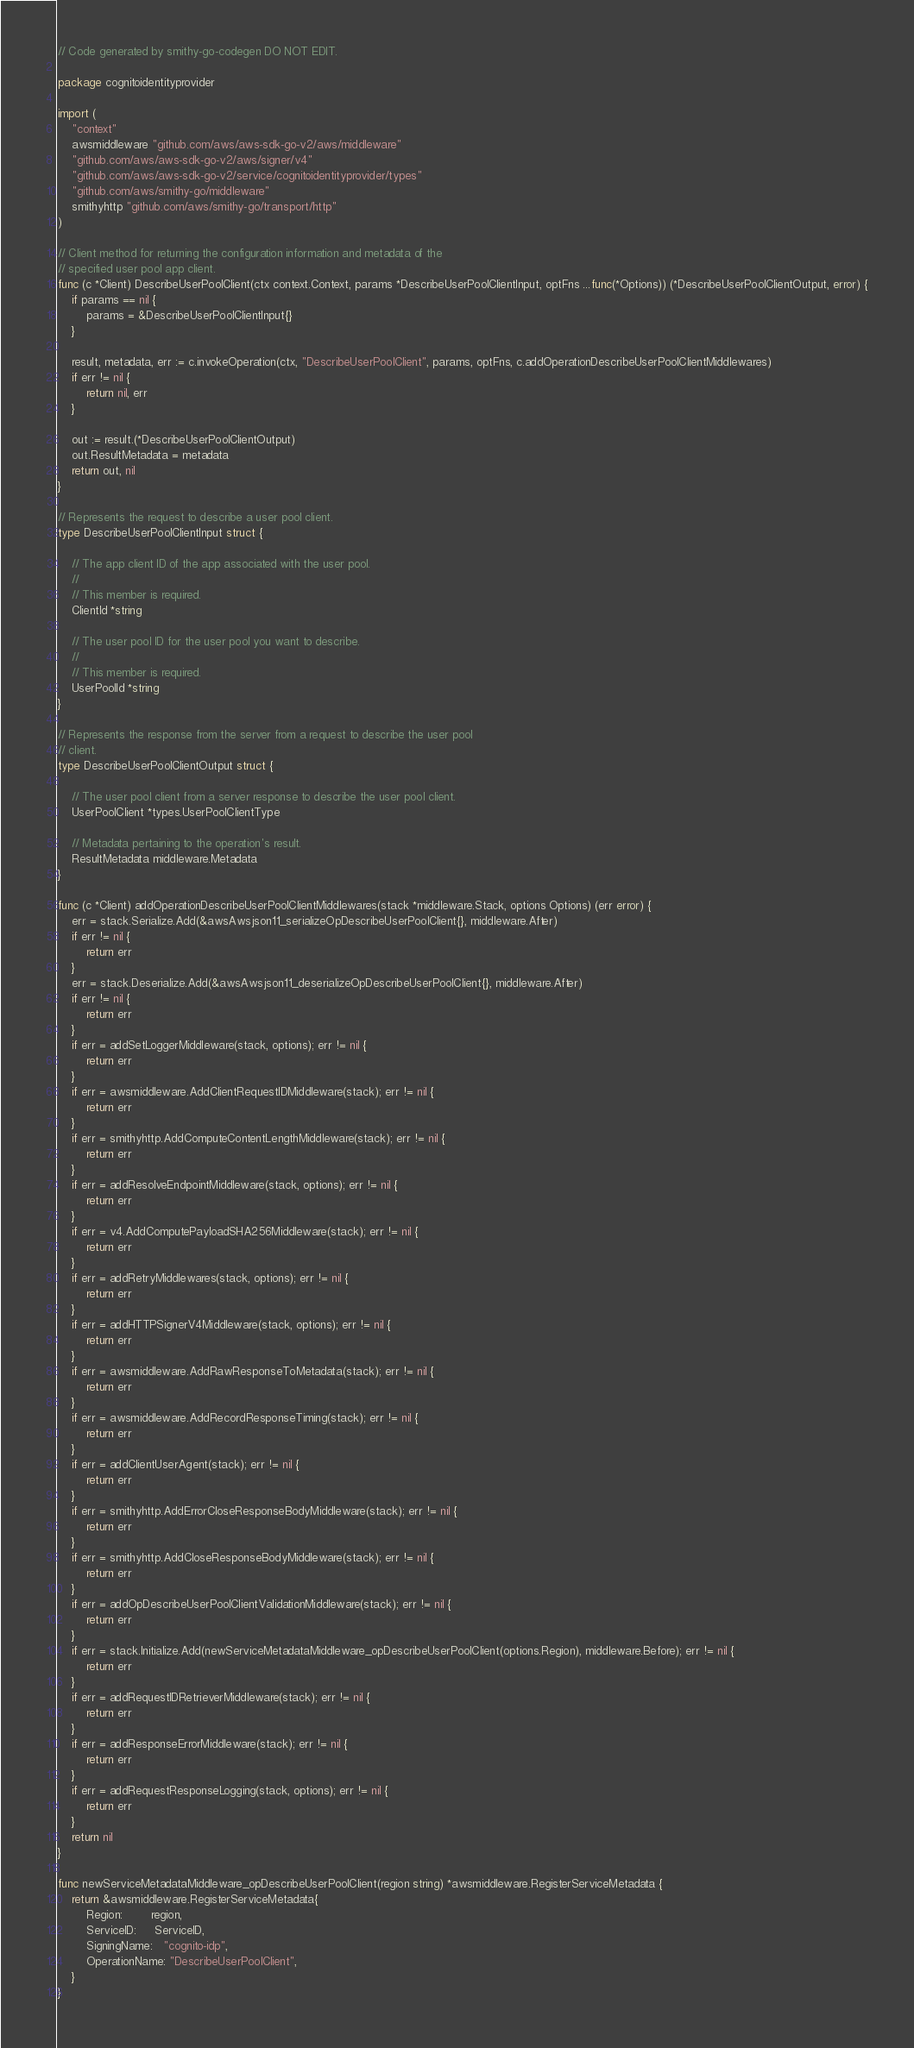Convert code to text. <code><loc_0><loc_0><loc_500><loc_500><_Go_>// Code generated by smithy-go-codegen DO NOT EDIT.

package cognitoidentityprovider

import (
	"context"
	awsmiddleware "github.com/aws/aws-sdk-go-v2/aws/middleware"
	"github.com/aws/aws-sdk-go-v2/aws/signer/v4"
	"github.com/aws/aws-sdk-go-v2/service/cognitoidentityprovider/types"
	"github.com/aws/smithy-go/middleware"
	smithyhttp "github.com/aws/smithy-go/transport/http"
)

// Client method for returning the configuration information and metadata of the
// specified user pool app client.
func (c *Client) DescribeUserPoolClient(ctx context.Context, params *DescribeUserPoolClientInput, optFns ...func(*Options)) (*DescribeUserPoolClientOutput, error) {
	if params == nil {
		params = &DescribeUserPoolClientInput{}
	}

	result, metadata, err := c.invokeOperation(ctx, "DescribeUserPoolClient", params, optFns, c.addOperationDescribeUserPoolClientMiddlewares)
	if err != nil {
		return nil, err
	}

	out := result.(*DescribeUserPoolClientOutput)
	out.ResultMetadata = metadata
	return out, nil
}

// Represents the request to describe a user pool client.
type DescribeUserPoolClientInput struct {

	// The app client ID of the app associated with the user pool.
	//
	// This member is required.
	ClientId *string

	// The user pool ID for the user pool you want to describe.
	//
	// This member is required.
	UserPoolId *string
}

// Represents the response from the server from a request to describe the user pool
// client.
type DescribeUserPoolClientOutput struct {

	// The user pool client from a server response to describe the user pool client.
	UserPoolClient *types.UserPoolClientType

	// Metadata pertaining to the operation's result.
	ResultMetadata middleware.Metadata
}

func (c *Client) addOperationDescribeUserPoolClientMiddlewares(stack *middleware.Stack, options Options) (err error) {
	err = stack.Serialize.Add(&awsAwsjson11_serializeOpDescribeUserPoolClient{}, middleware.After)
	if err != nil {
		return err
	}
	err = stack.Deserialize.Add(&awsAwsjson11_deserializeOpDescribeUserPoolClient{}, middleware.After)
	if err != nil {
		return err
	}
	if err = addSetLoggerMiddleware(stack, options); err != nil {
		return err
	}
	if err = awsmiddleware.AddClientRequestIDMiddleware(stack); err != nil {
		return err
	}
	if err = smithyhttp.AddComputeContentLengthMiddleware(stack); err != nil {
		return err
	}
	if err = addResolveEndpointMiddleware(stack, options); err != nil {
		return err
	}
	if err = v4.AddComputePayloadSHA256Middleware(stack); err != nil {
		return err
	}
	if err = addRetryMiddlewares(stack, options); err != nil {
		return err
	}
	if err = addHTTPSignerV4Middleware(stack, options); err != nil {
		return err
	}
	if err = awsmiddleware.AddRawResponseToMetadata(stack); err != nil {
		return err
	}
	if err = awsmiddleware.AddRecordResponseTiming(stack); err != nil {
		return err
	}
	if err = addClientUserAgent(stack); err != nil {
		return err
	}
	if err = smithyhttp.AddErrorCloseResponseBodyMiddleware(stack); err != nil {
		return err
	}
	if err = smithyhttp.AddCloseResponseBodyMiddleware(stack); err != nil {
		return err
	}
	if err = addOpDescribeUserPoolClientValidationMiddleware(stack); err != nil {
		return err
	}
	if err = stack.Initialize.Add(newServiceMetadataMiddleware_opDescribeUserPoolClient(options.Region), middleware.Before); err != nil {
		return err
	}
	if err = addRequestIDRetrieverMiddleware(stack); err != nil {
		return err
	}
	if err = addResponseErrorMiddleware(stack); err != nil {
		return err
	}
	if err = addRequestResponseLogging(stack, options); err != nil {
		return err
	}
	return nil
}

func newServiceMetadataMiddleware_opDescribeUserPoolClient(region string) *awsmiddleware.RegisterServiceMetadata {
	return &awsmiddleware.RegisterServiceMetadata{
		Region:        region,
		ServiceID:     ServiceID,
		SigningName:   "cognito-idp",
		OperationName: "DescribeUserPoolClient",
	}
}
</code> 